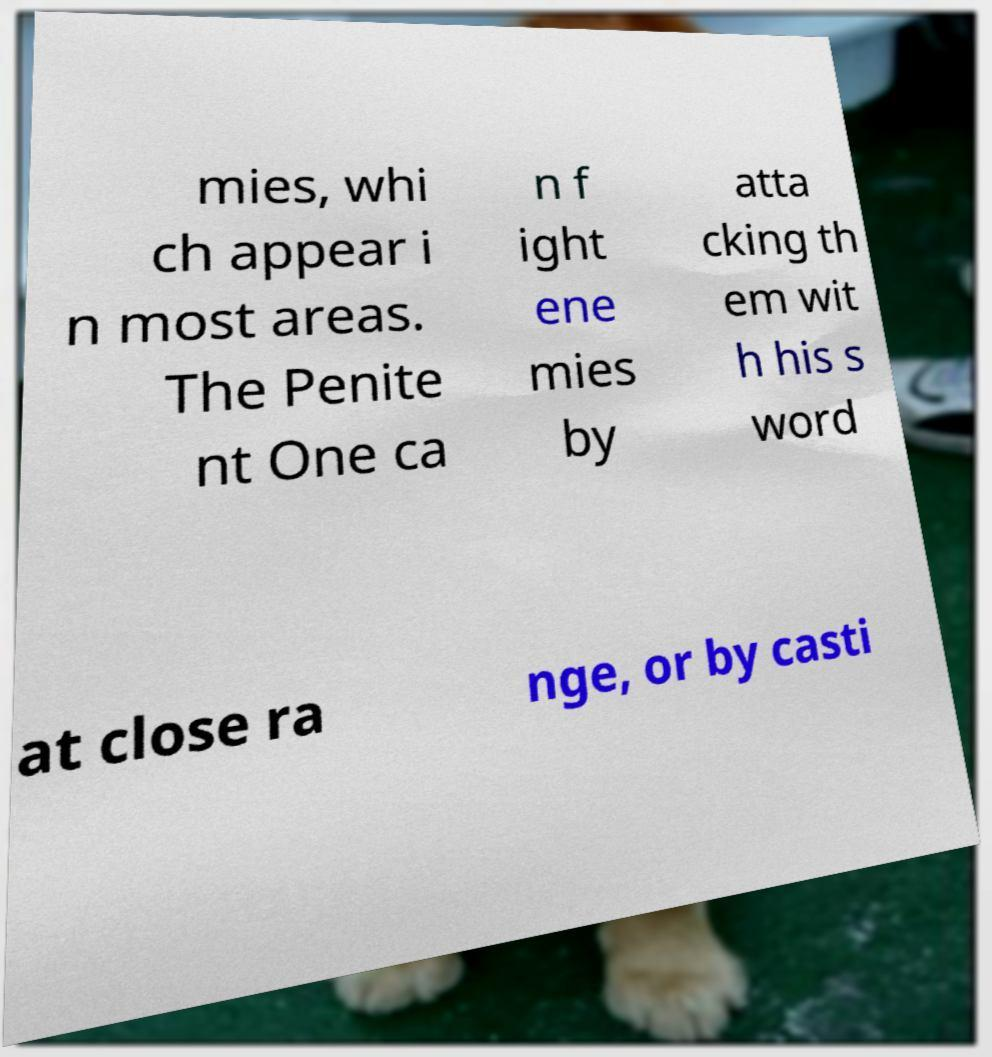Can you accurately transcribe the text from the provided image for me? mies, whi ch appear i n most areas. The Penite nt One ca n f ight ene mies by atta cking th em wit h his s word at close ra nge, or by casti 